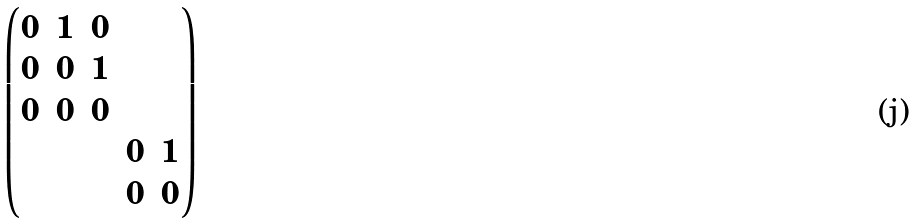Convert formula to latex. <formula><loc_0><loc_0><loc_500><loc_500>\begin{pmatrix} 0 & 1 & 0 & & \\ 0 & 0 & 1 & & \\ 0 & 0 & 0 & & \\ & & & 0 & 1 \\ & & & 0 & 0 \end{pmatrix}</formula> 